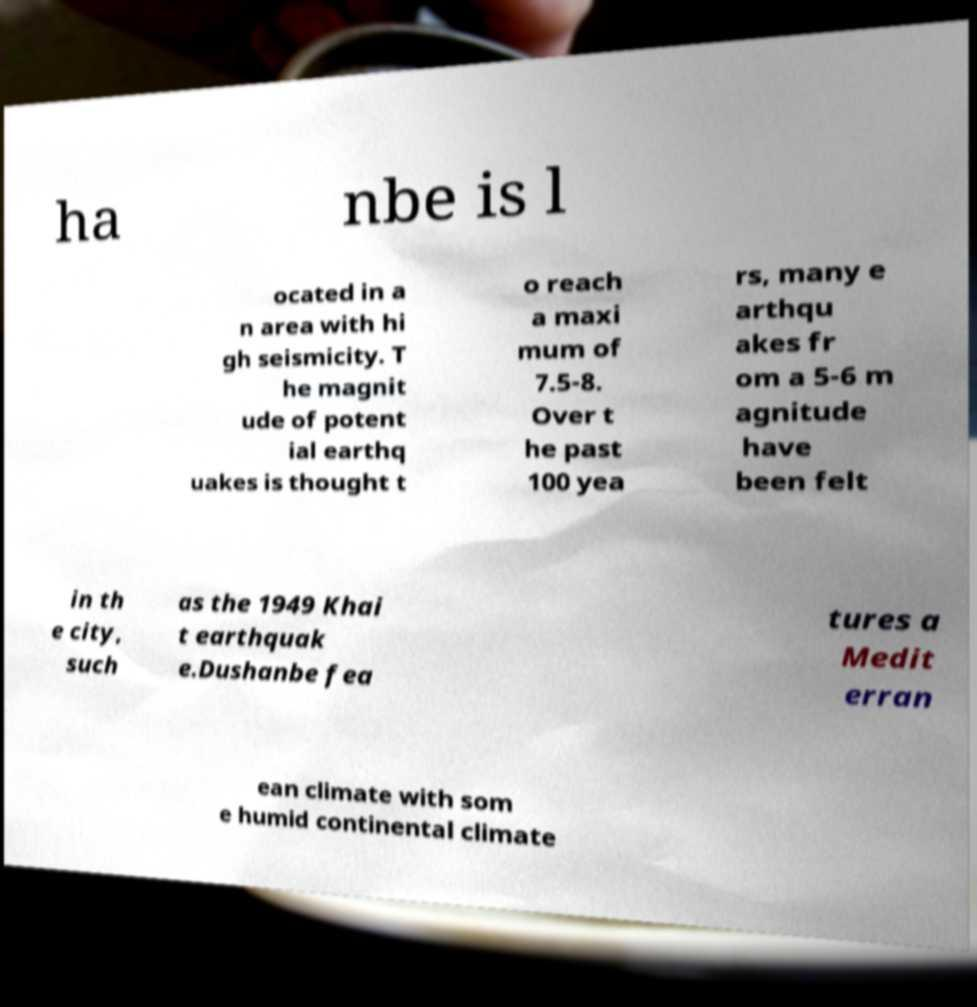Please identify and transcribe the text found in this image. ha nbe is l ocated in a n area with hi gh seismicity. T he magnit ude of potent ial earthq uakes is thought t o reach a maxi mum of 7.5-8. Over t he past 100 yea rs, many e arthqu akes fr om a 5-6 m agnitude have been felt in th e city, such as the 1949 Khai t earthquak e.Dushanbe fea tures a Medit erran ean climate with som e humid continental climate 